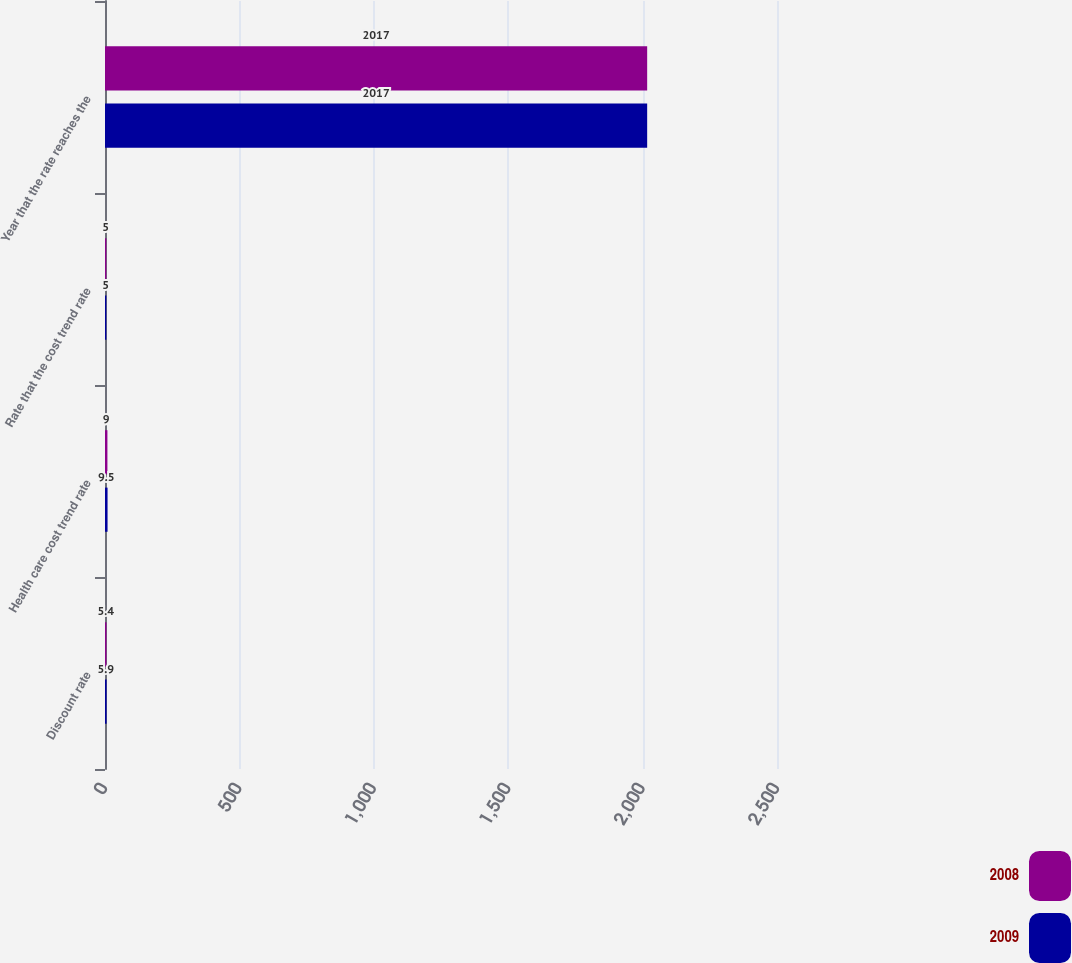Convert chart to OTSL. <chart><loc_0><loc_0><loc_500><loc_500><stacked_bar_chart><ecel><fcel>Discount rate<fcel>Health care cost trend rate<fcel>Rate that the cost trend rate<fcel>Year that the rate reaches the<nl><fcel>2008<fcel>5.4<fcel>9<fcel>5<fcel>2017<nl><fcel>2009<fcel>5.9<fcel>9.5<fcel>5<fcel>2017<nl></chart> 